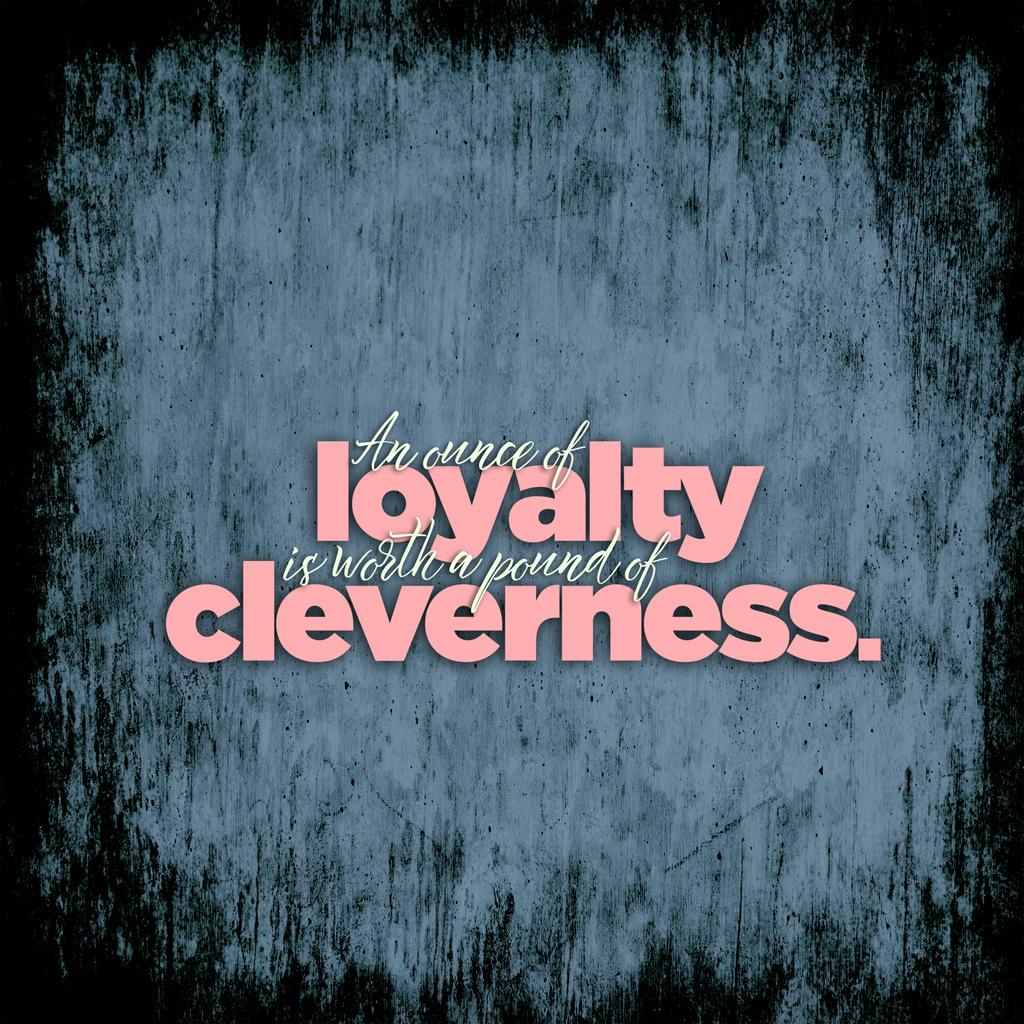<image>
Summarize the visual content of the image. Sign that says an ounce of loyalty is worth a pound of cleverness 